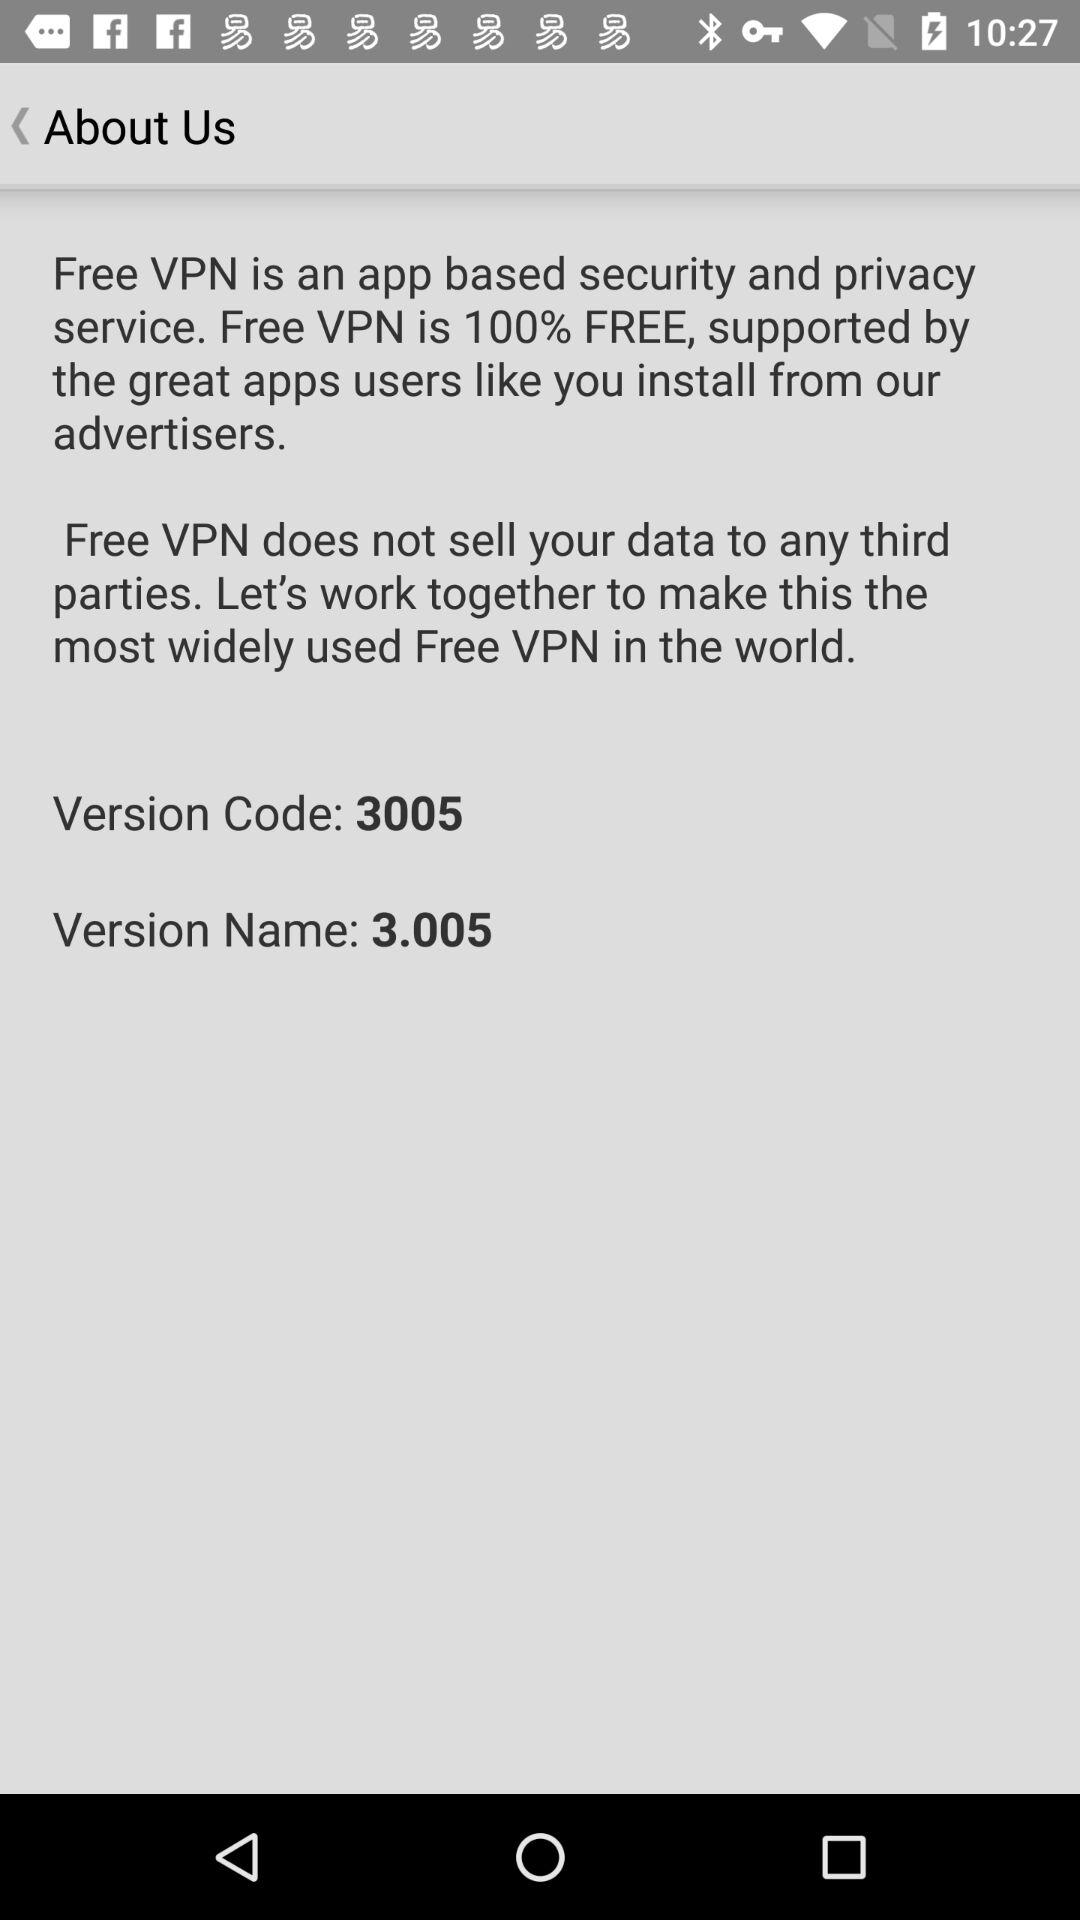What is the version code? The version code is 3005. 